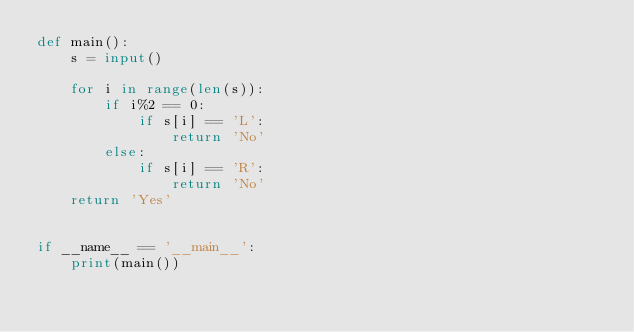<code> <loc_0><loc_0><loc_500><loc_500><_Python_>def main():
	s = input()
	
	for i in range(len(s)):
		if i%2 == 0:
			if s[i] == 'L':
				return 'No'
		else:
			if s[i] == 'R':
				return 'No'
	return 'Yes'
	
	
if __name__ == '__main__':
	print(main())</code> 